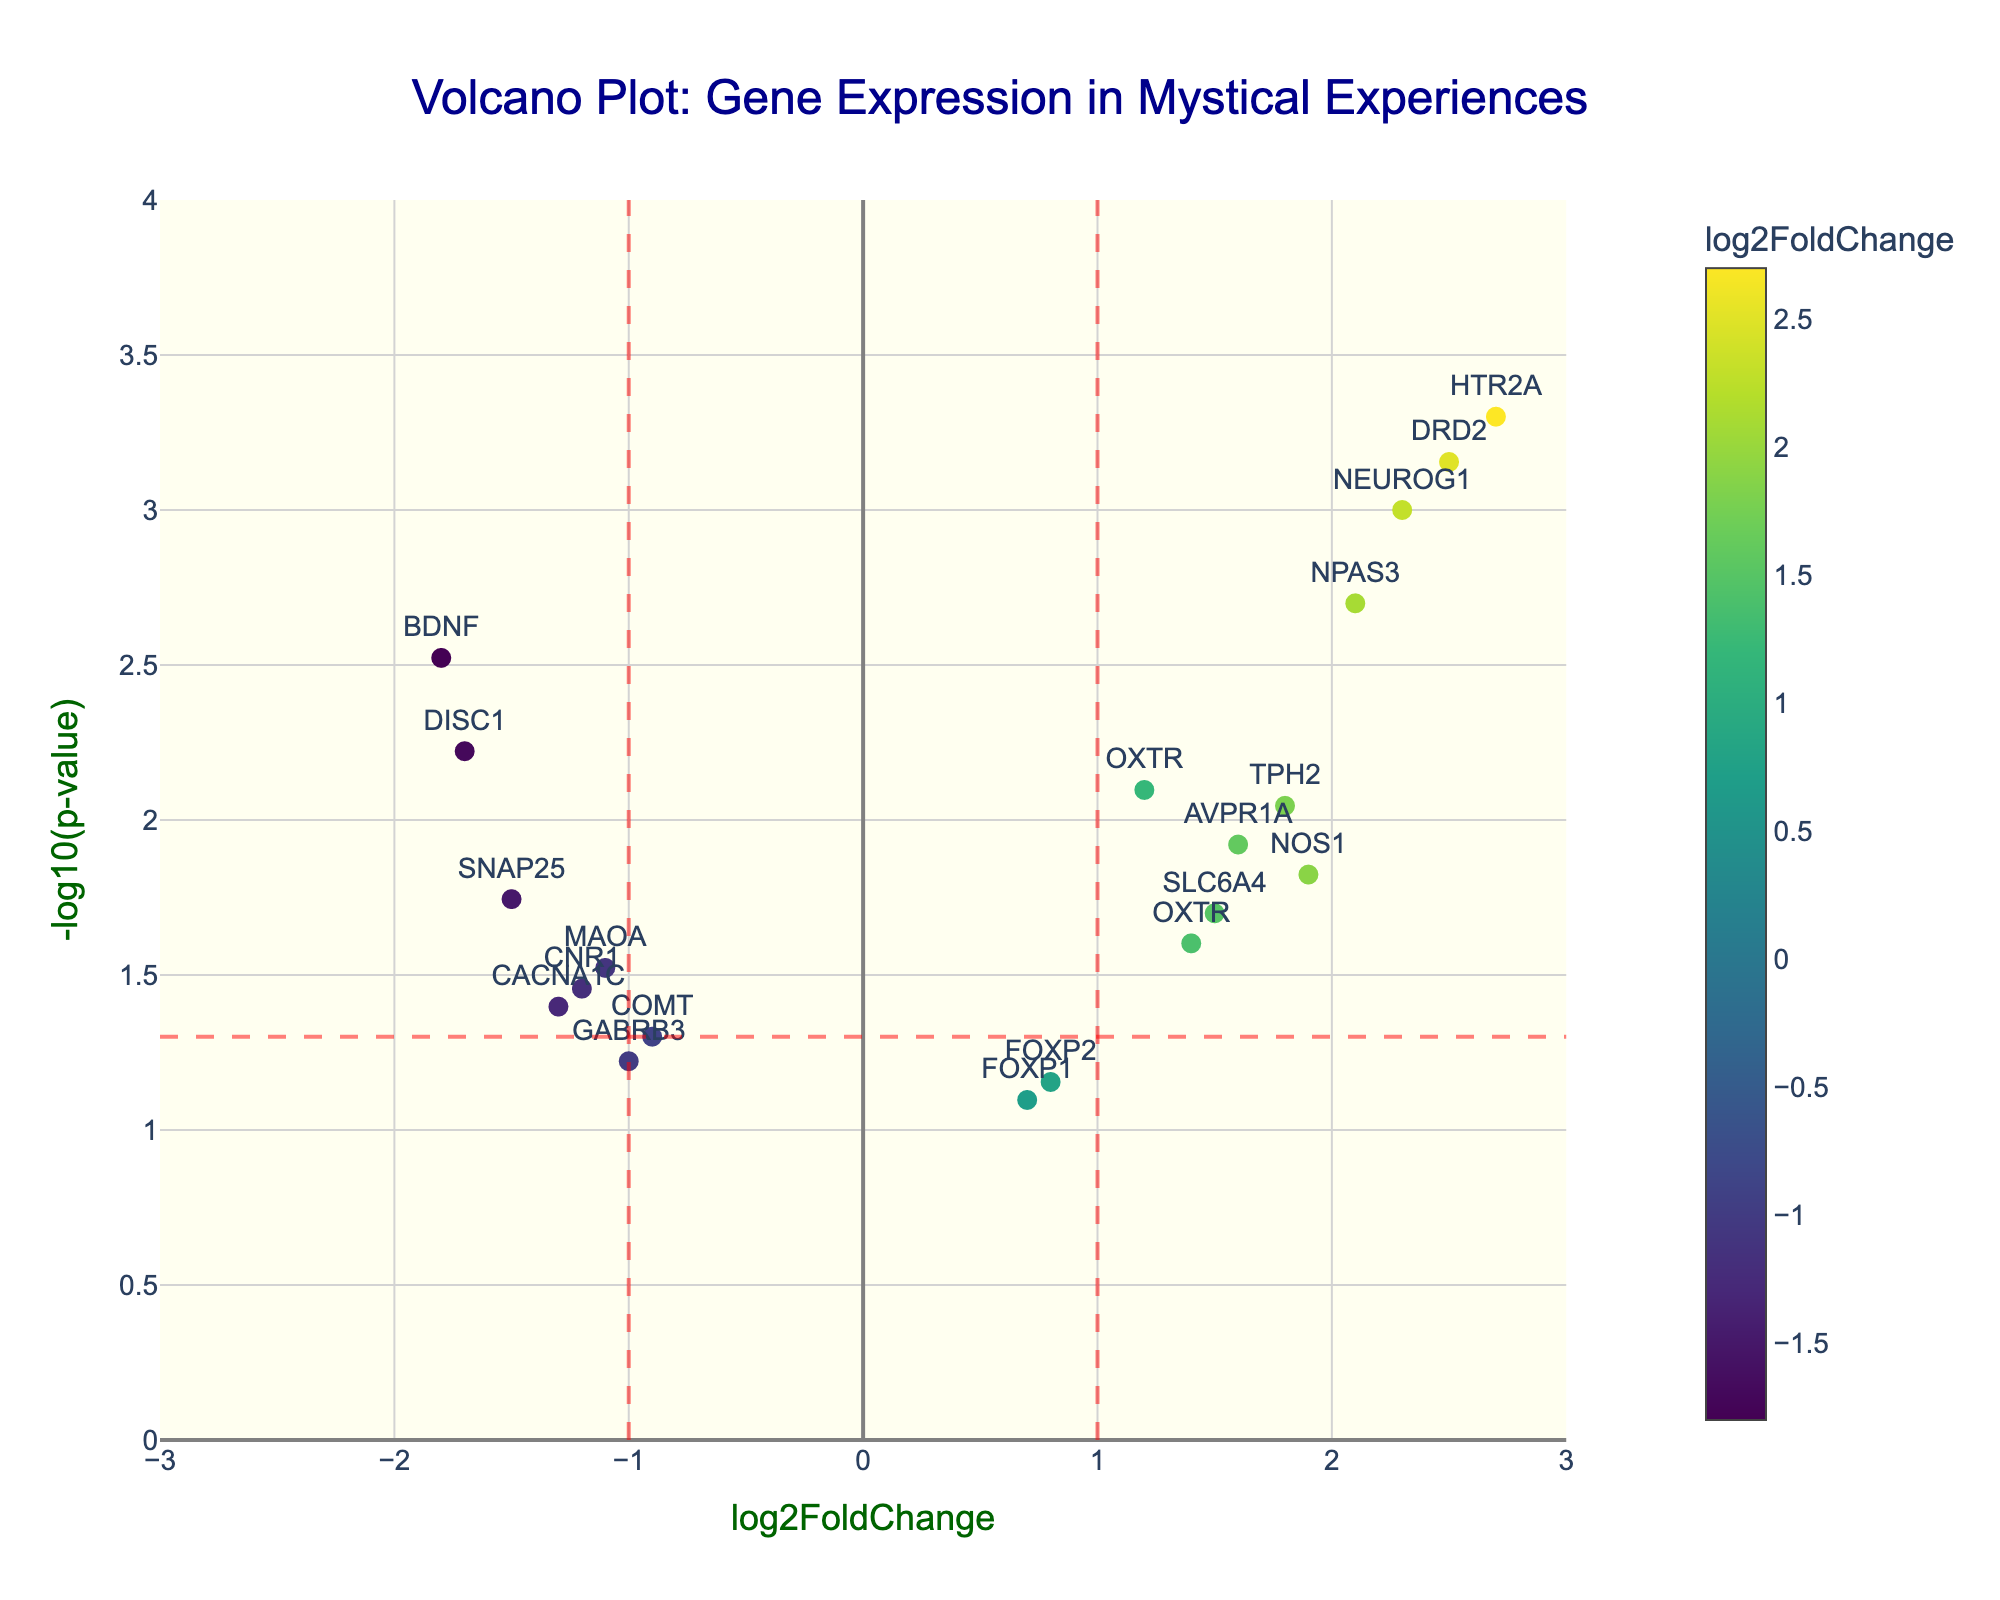What's the title of the figure? The title can usually be found at the top of the figure; it provides a summary of the plot's content. In this case, the title is "Volcano Plot: Gene Expression in Mystical Experiences".
Answer: Volcano Plot: Gene Expression in Mystical Experiences What do the x-axis and y-axis represent? The axes are labeled to tell us what each dimension in the plot represents. Here, the x-axis represents the `log2FoldChange`, and the y-axis represents `-log10(p-value)`.
Answer: x-axis: log2FoldChange, y-axis: -log10(p-value) How many genes have a log2FoldChange greater than 2? By looking at the x-axis, locate the points that are to the right of 2. These points represent genes with a log2FoldChange greater than 2. The genes are NEUROG1, HTR2A, NPAS3, and DRD2.
Answer: 4 Which gene has the smallest p-value? The y-axis represents `-log10(p-value)`, so the highest point on the y-axis has the smallest p-value because the negative logarithm of a smaller number is larger. This gene is HTR2A.
Answer: HTR2A Are there more genes up-regulated or down-regulated? Up-regulated genes have positive log2FoldChanges (right of x=0), and down-regulated genes have negative log2FoldChanges (left of x=0). Count the points on each side to determine which is more frequent.
Answer: More genes are up-regulated Which gene has the most statistically significant expression change and what is the p-value? The most statistically significant change is indicated by the highest `-log10(p-value)` value on the y-axis. The highest point corresponds to HTR2A, which also has the smallest p-value of 0.0005.
Answer: HTR2A, p-value: 0.0005 How many genes have both log2FoldChange values greater than 1 and p-values less than 0.05? Identify the genes that are to the right of x=1 and above the horizontal line representing p-value = 0.05 (threshold line y = 1.3010). The genes fitting these criteria are NEUROG1, HTR2A, NPAS3, and DRD2.
Answer: 4 Which two genes have log2FoldChange values that are closest to each other? Check the x-coordinates of the markers and find the pair with the minimum absolute difference. OXTR appears twice with values 1.2 and 1.4.
Answer: OXTR (1.2 and 1.4) What is the range of log2FoldChange for the displayed genes? The range is determined by the minimum and maximum values on the x-axis. The points span from approximately -1.8 (BDNF) to 2.7 (HTR2A).
Answer: -1.8 to 2.7 Are there any genes with a log2FoldChange close to 0 and statistically significant p-values? Look for points near the x=0 line and above the horizontal threshold line for p = 0.05. FOXP2 with a log2FoldChange of 0.8 and p-value of 0.07 is not above the significance threshold, so there are no such genes.
Answer: No 